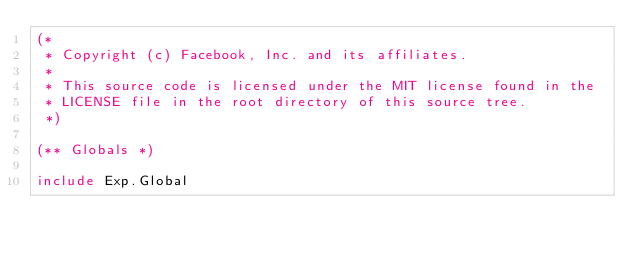<code> <loc_0><loc_0><loc_500><loc_500><_OCaml_>(*
 * Copyright (c) Facebook, Inc. and its affiliates.
 *
 * This source code is licensed under the MIT license found in the
 * LICENSE file in the root directory of this source tree.
 *)

(** Globals *)

include Exp.Global
</code> 